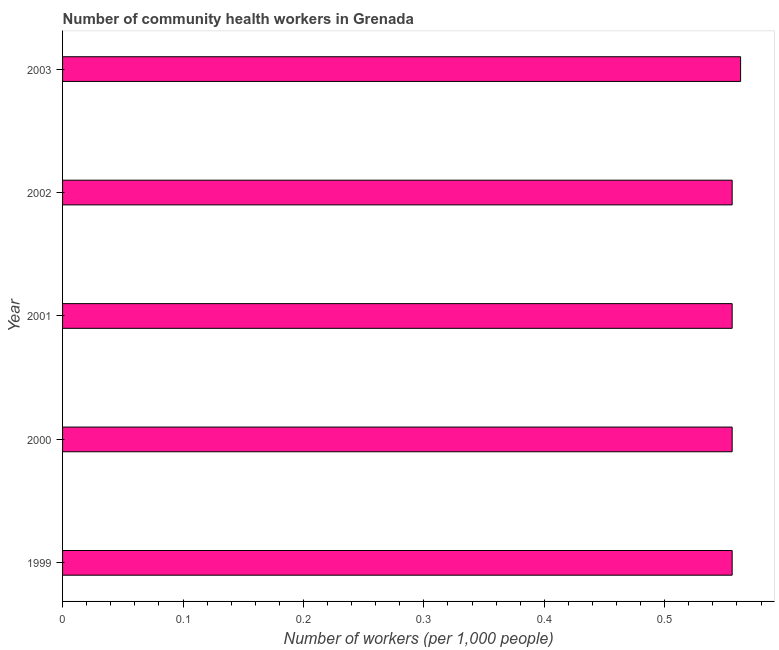Does the graph contain any zero values?
Your response must be concise. No. What is the title of the graph?
Make the answer very short. Number of community health workers in Grenada. What is the label or title of the X-axis?
Provide a short and direct response. Number of workers (per 1,0 people). What is the label or title of the Y-axis?
Make the answer very short. Year. What is the number of community health workers in 2001?
Your response must be concise. 0.56. Across all years, what is the maximum number of community health workers?
Your answer should be very brief. 0.56. Across all years, what is the minimum number of community health workers?
Make the answer very short. 0.56. What is the sum of the number of community health workers?
Offer a terse response. 2.79. What is the average number of community health workers per year?
Your answer should be very brief. 0.56. What is the median number of community health workers?
Keep it short and to the point. 0.56. In how many years, is the number of community health workers greater than 0.34 ?
Ensure brevity in your answer.  5. Is the number of community health workers in 1999 less than that in 2003?
Offer a very short reply. Yes. What is the difference between the highest and the second highest number of community health workers?
Ensure brevity in your answer.  0.01. Is the sum of the number of community health workers in 1999 and 2003 greater than the maximum number of community health workers across all years?
Give a very brief answer. Yes. In how many years, is the number of community health workers greater than the average number of community health workers taken over all years?
Offer a very short reply. 1. Are all the bars in the graph horizontal?
Give a very brief answer. Yes. What is the difference between two consecutive major ticks on the X-axis?
Ensure brevity in your answer.  0.1. Are the values on the major ticks of X-axis written in scientific E-notation?
Make the answer very short. No. What is the Number of workers (per 1,000 people) in 1999?
Ensure brevity in your answer.  0.56. What is the Number of workers (per 1,000 people) in 2000?
Your answer should be very brief. 0.56. What is the Number of workers (per 1,000 people) in 2001?
Give a very brief answer. 0.56. What is the Number of workers (per 1,000 people) in 2002?
Provide a short and direct response. 0.56. What is the Number of workers (per 1,000 people) of 2003?
Keep it short and to the point. 0.56. What is the difference between the Number of workers (per 1,000 people) in 1999 and 2000?
Offer a very short reply. 0. What is the difference between the Number of workers (per 1,000 people) in 1999 and 2001?
Offer a very short reply. 0. What is the difference between the Number of workers (per 1,000 people) in 1999 and 2003?
Provide a succinct answer. -0.01. What is the difference between the Number of workers (per 1,000 people) in 2000 and 2002?
Give a very brief answer. 0. What is the difference between the Number of workers (per 1,000 people) in 2000 and 2003?
Keep it short and to the point. -0.01. What is the difference between the Number of workers (per 1,000 people) in 2001 and 2002?
Your response must be concise. 0. What is the difference between the Number of workers (per 1,000 people) in 2001 and 2003?
Keep it short and to the point. -0.01. What is the difference between the Number of workers (per 1,000 people) in 2002 and 2003?
Your response must be concise. -0.01. What is the ratio of the Number of workers (per 1,000 people) in 1999 to that in 2000?
Keep it short and to the point. 1. What is the ratio of the Number of workers (per 1,000 people) in 1999 to that in 2001?
Provide a succinct answer. 1. What is the ratio of the Number of workers (per 1,000 people) in 2000 to that in 2001?
Your response must be concise. 1. What is the ratio of the Number of workers (per 1,000 people) in 2001 to that in 2003?
Make the answer very short. 0.99. 